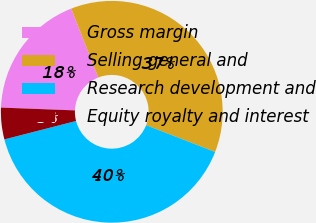<chart> <loc_0><loc_0><loc_500><loc_500><pie_chart><fcel>Gross margin<fcel>Selling general and<fcel>Research development and<fcel>Equity royalty and interest<nl><fcel>18.43%<fcel>36.87%<fcel>40.09%<fcel>4.61%<nl></chart> 